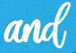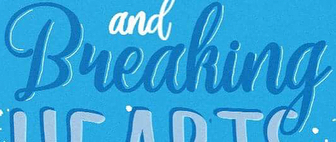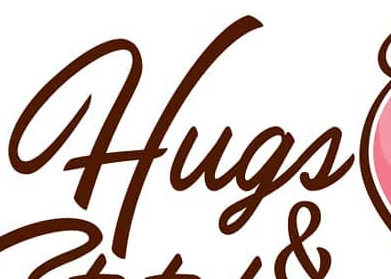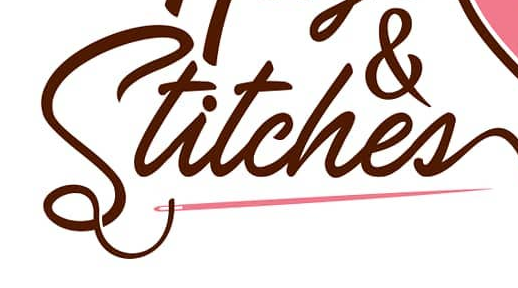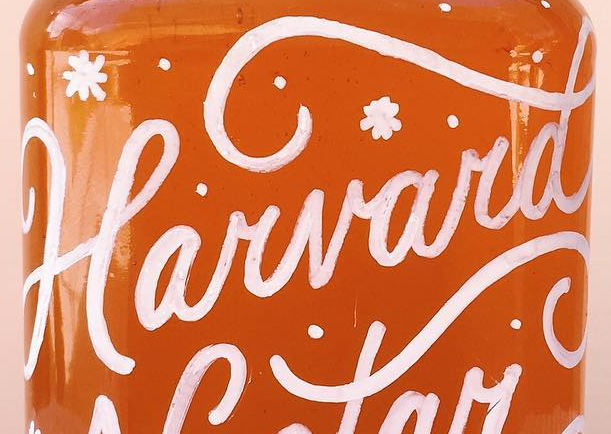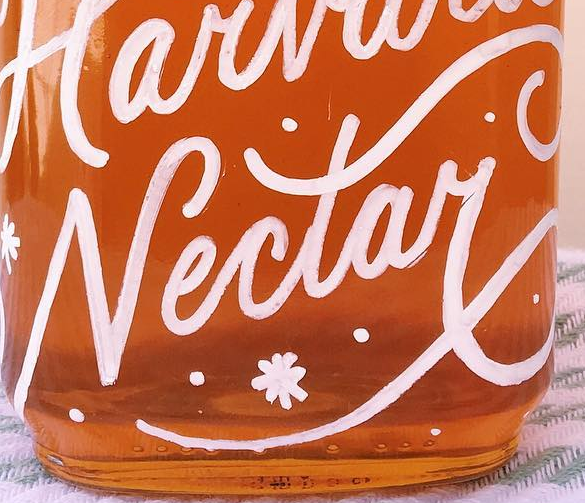What words are shown in these images in order, separated by a semicolon? and; Bueaking; Hugs; Stitches; Harvard; Nectay 